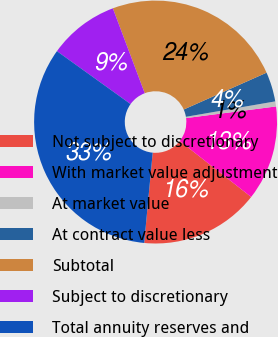<chart> <loc_0><loc_0><loc_500><loc_500><pie_chart><fcel>Not subject to discretionary<fcel>With market value adjustment<fcel>At market value<fcel>At contract value less<fcel>Subtotal<fcel>Subject to discretionary<fcel>Total annuity reserves and<nl><fcel>15.91%<fcel>12.63%<fcel>0.67%<fcel>3.94%<fcel>24.06%<fcel>9.36%<fcel>33.42%<nl></chart> 